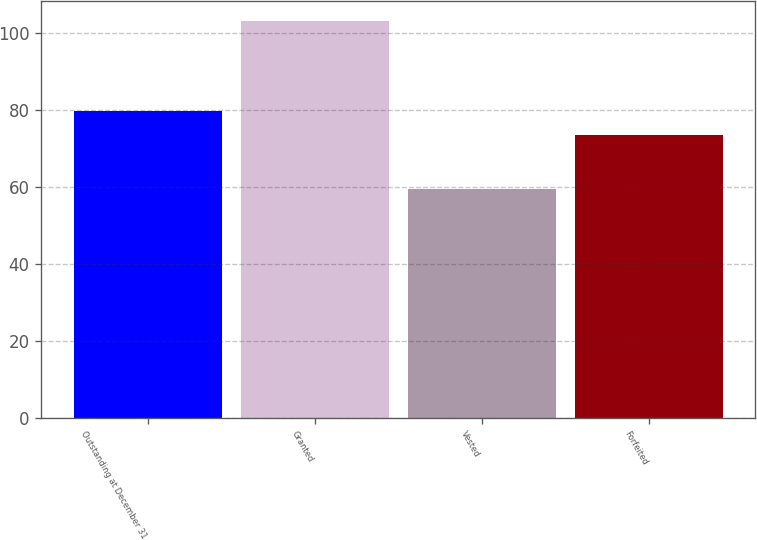Convert chart. <chart><loc_0><loc_0><loc_500><loc_500><bar_chart><fcel>Outstanding at December 31<fcel>Granted<fcel>Vested<fcel>Forfeited<nl><fcel>79.9<fcel>103.31<fcel>59.41<fcel>73.45<nl></chart> 